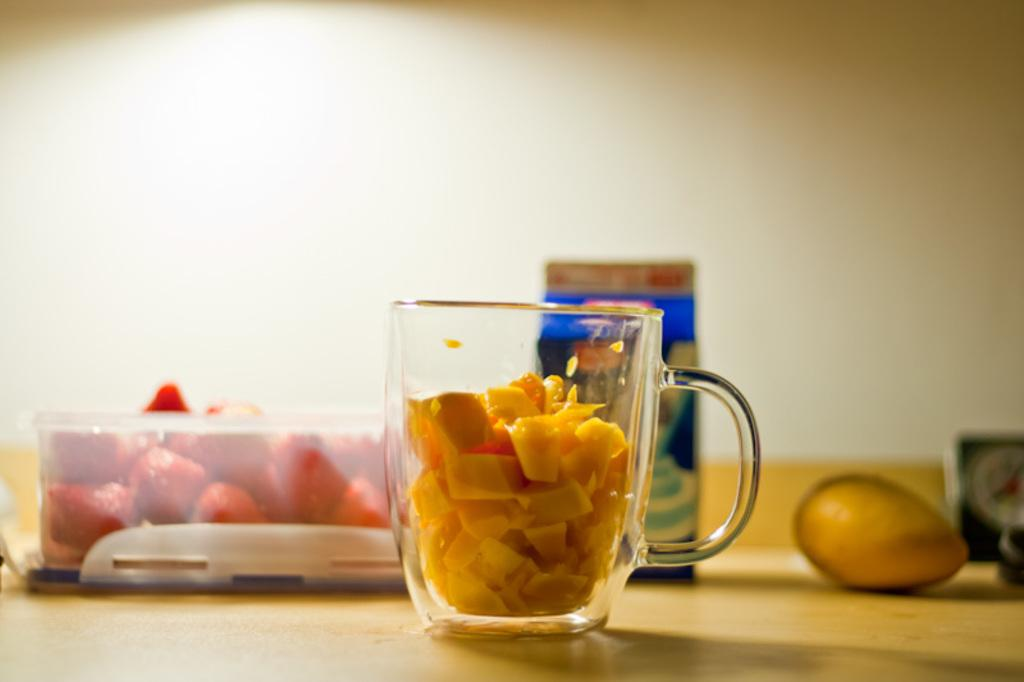What is the main piece of furniture in the image? There is a table in the image. What is placed on the table? There is a jug and a box with fruits on the table. Can you identify any specific fruit in the image? Yes, there is a mango visible in the image. What can be seen in the background of the image? There is a wall in the background of the image. What type of pies are being served in the image? There are no pies present in the image; it features a table with a jug, a box with fruits, and a mango. How many snakes can be seen slithering on the table in the image? There are no snakes present in the image; it only features a table, a jug, a box with fruits, and a mango. 